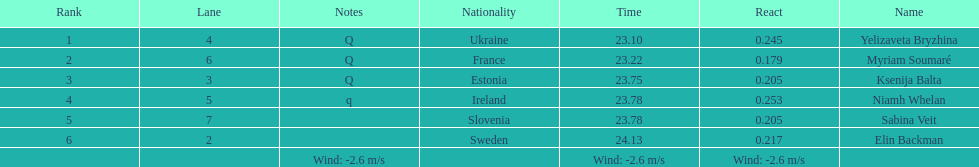Who is the first ranking player? Yelizaveta Bryzhina. 